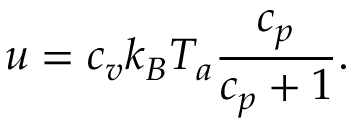Convert formula to latex. <formula><loc_0><loc_0><loc_500><loc_500>u = c _ { v } k _ { B } T _ { a } { \frac { c _ { p } } { c _ { p } + 1 } } .</formula> 